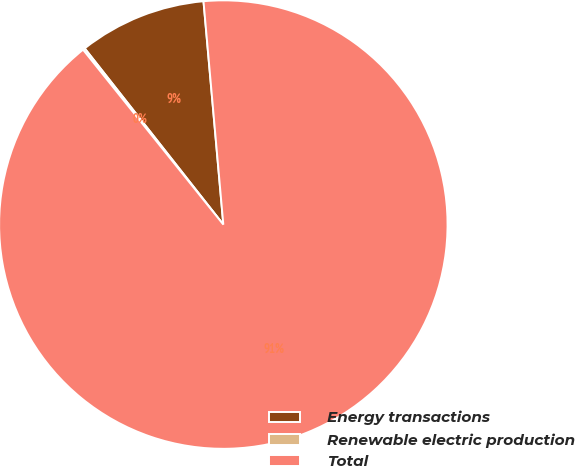<chart> <loc_0><loc_0><loc_500><loc_500><pie_chart><fcel>Energy transactions<fcel>Renewable electric production<fcel>Total<nl><fcel>9.2%<fcel>0.15%<fcel>90.65%<nl></chart> 